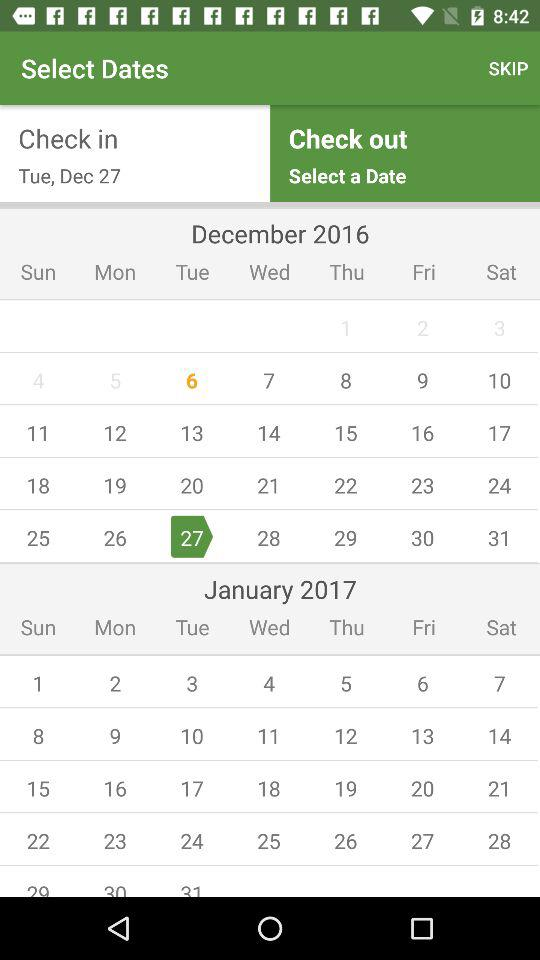What is the check out date?
When the provided information is insufficient, respond with <no answer>. <no answer> 